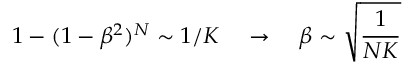<formula> <loc_0><loc_0><loc_500><loc_500>1 - ( 1 - \beta ^ { 2 } ) ^ { N } \sim 1 / K \quad \rightarrow \quad \beta \sim \sqrt { \frac { 1 } { N K } }</formula> 